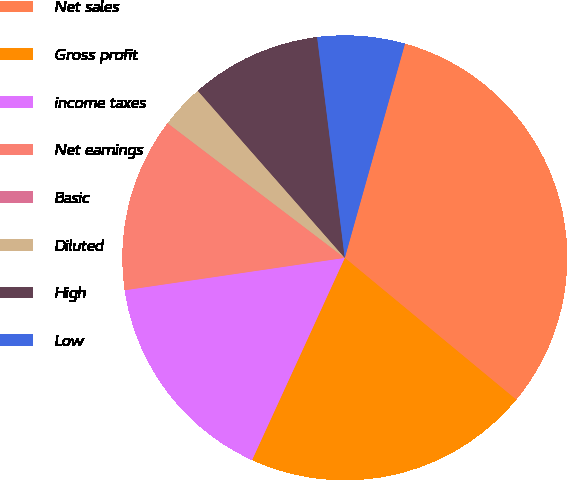Convert chart. <chart><loc_0><loc_0><loc_500><loc_500><pie_chart><fcel>Net sales<fcel>Gross profit<fcel>income taxes<fcel>Net earnings<fcel>Basic<fcel>Diluted<fcel>High<fcel>Low<nl><fcel>31.64%<fcel>20.84%<fcel>15.83%<fcel>12.66%<fcel>0.01%<fcel>3.17%<fcel>9.5%<fcel>6.34%<nl></chart> 